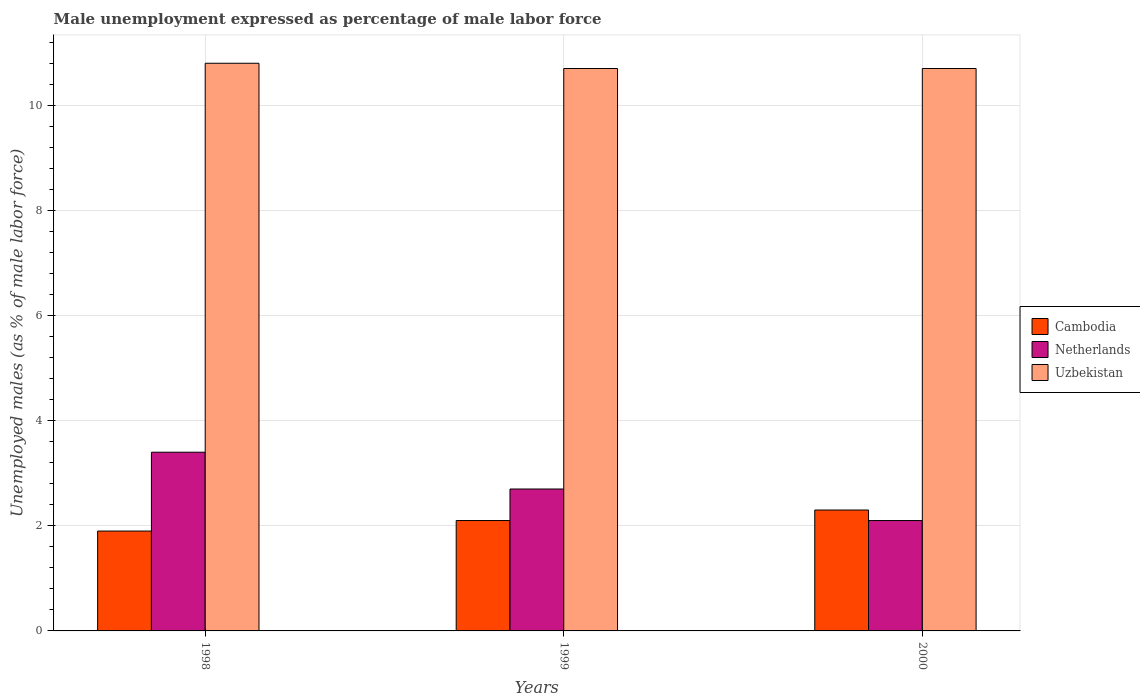How many groups of bars are there?
Ensure brevity in your answer.  3. Are the number of bars on each tick of the X-axis equal?
Keep it short and to the point. Yes. How many bars are there on the 1st tick from the right?
Make the answer very short. 3. What is the label of the 1st group of bars from the left?
Provide a short and direct response. 1998. What is the unemployment in males in in Cambodia in 1998?
Give a very brief answer. 1.9. Across all years, what is the maximum unemployment in males in in Netherlands?
Give a very brief answer. 3.4. Across all years, what is the minimum unemployment in males in in Cambodia?
Make the answer very short. 1.9. In which year was the unemployment in males in in Cambodia maximum?
Give a very brief answer. 2000. What is the total unemployment in males in in Uzbekistan in the graph?
Offer a terse response. 32.2. What is the difference between the unemployment in males in in Cambodia in 1998 and that in 2000?
Your answer should be compact. -0.4. What is the difference between the unemployment in males in in Uzbekistan in 2000 and the unemployment in males in in Cambodia in 1998?
Your response must be concise. 8.8. What is the average unemployment in males in in Cambodia per year?
Ensure brevity in your answer.  2.1. In the year 1998, what is the difference between the unemployment in males in in Netherlands and unemployment in males in in Cambodia?
Make the answer very short. 1.5. In how many years, is the unemployment in males in in Netherlands greater than 10.8 %?
Keep it short and to the point. 0. What is the ratio of the unemployment in males in in Uzbekistan in 1998 to that in 1999?
Keep it short and to the point. 1.01. Is the difference between the unemployment in males in in Netherlands in 1999 and 2000 greater than the difference between the unemployment in males in in Cambodia in 1999 and 2000?
Provide a succinct answer. Yes. What is the difference between the highest and the second highest unemployment in males in in Cambodia?
Offer a terse response. 0.2. What is the difference between the highest and the lowest unemployment in males in in Uzbekistan?
Give a very brief answer. 0.1. In how many years, is the unemployment in males in in Uzbekistan greater than the average unemployment in males in in Uzbekistan taken over all years?
Your answer should be very brief. 1. Is the sum of the unemployment in males in in Uzbekistan in 1998 and 1999 greater than the maximum unemployment in males in in Cambodia across all years?
Ensure brevity in your answer.  Yes. What does the 1st bar from the left in 1999 represents?
Your answer should be very brief. Cambodia. Is it the case that in every year, the sum of the unemployment in males in in Cambodia and unemployment in males in in Netherlands is greater than the unemployment in males in in Uzbekistan?
Provide a short and direct response. No. How many years are there in the graph?
Provide a short and direct response. 3. What is the difference between two consecutive major ticks on the Y-axis?
Your answer should be very brief. 2. Does the graph contain grids?
Your response must be concise. Yes. How many legend labels are there?
Keep it short and to the point. 3. How are the legend labels stacked?
Your answer should be very brief. Vertical. What is the title of the graph?
Give a very brief answer. Male unemployment expressed as percentage of male labor force. What is the label or title of the X-axis?
Ensure brevity in your answer.  Years. What is the label or title of the Y-axis?
Give a very brief answer. Unemployed males (as % of male labor force). What is the Unemployed males (as % of male labor force) in Cambodia in 1998?
Give a very brief answer. 1.9. What is the Unemployed males (as % of male labor force) of Netherlands in 1998?
Provide a short and direct response. 3.4. What is the Unemployed males (as % of male labor force) in Uzbekistan in 1998?
Offer a very short reply. 10.8. What is the Unemployed males (as % of male labor force) of Cambodia in 1999?
Offer a terse response. 2.1. What is the Unemployed males (as % of male labor force) of Netherlands in 1999?
Ensure brevity in your answer.  2.7. What is the Unemployed males (as % of male labor force) in Uzbekistan in 1999?
Make the answer very short. 10.7. What is the Unemployed males (as % of male labor force) in Cambodia in 2000?
Offer a terse response. 2.3. What is the Unemployed males (as % of male labor force) in Netherlands in 2000?
Offer a terse response. 2.1. What is the Unemployed males (as % of male labor force) of Uzbekistan in 2000?
Make the answer very short. 10.7. Across all years, what is the maximum Unemployed males (as % of male labor force) in Cambodia?
Give a very brief answer. 2.3. Across all years, what is the maximum Unemployed males (as % of male labor force) of Netherlands?
Provide a succinct answer. 3.4. Across all years, what is the maximum Unemployed males (as % of male labor force) in Uzbekistan?
Offer a terse response. 10.8. Across all years, what is the minimum Unemployed males (as % of male labor force) in Cambodia?
Your response must be concise. 1.9. Across all years, what is the minimum Unemployed males (as % of male labor force) in Netherlands?
Offer a very short reply. 2.1. Across all years, what is the minimum Unemployed males (as % of male labor force) of Uzbekistan?
Ensure brevity in your answer.  10.7. What is the total Unemployed males (as % of male labor force) in Cambodia in the graph?
Your answer should be very brief. 6.3. What is the total Unemployed males (as % of male labor force) of Uzbekistan in the graph?
Your response must be concise. 32.2. What is the difference between the Unemployed males (as % of male labor force) in Cambodia in 1998 and that in 1999?
Offer a terse response. -0.2. What is the difference between the Unemployed males (as % of male labor force) in Netherlands in 1998 and that in 1999?
Your response must be concise. 0.7. What is the difference between the Unemployed males (as % of male labor force) in Uzbekistan in 1998 and that in 2000?
Offer a terse response. 0.1. What is the difference between the Unemployed males (as % of male labor force) of Netherlands in 1999 and that in 2000?
Offer a very short reply. 0.6. What is the difference between the Unemployed males (as % of male labor force) of Uzbekistan in 1999 and that in 2000?
Offer a terse response. 0. What is the difference between the Unemployed males (as % of male labor force) of Cambodia in 1998 and the Unemployed males (as % of male labor force) of Netherlands in 1999?
Keep it short and to the point. -0.8. What is the difference between the Unemployed males (as % of male labor force) in Cambodia in 1998 and the Unemployed males (as % of male labor force) in Uzbekistan in 1999?
Provide a short and direct response. -8.8. What is the difference between the Unemployed males (as % of male labor force) in Cambodia in 1998 and the Unemployed males (as % of male labor force) in Uzbekistan in 2000?
Your answer should be very brief. -8.8. What is the difference between the Unemployed males (as % of male labor force) of Netherlands in 1998 and the Unemployed males (as % of male labor force) of Uzbekistan in 2000?
Give a very brief answer. -7.3. What is the difference between the Unemployed males (as % of male labor force) of Cambodia in 1999 and the Unemployed males (as % of male labor force) of Netherlands in 2000?
Offer a very short reply. 0. What is the difference between the Unemployed males (as % of male labor force) of Cambodia in 1999 and the Unemployed males (as % of male labor force) of Uzbekistan in 2000?
Provide a short and direct response. -8.6. What is the average Unemployed males (as % of male labor force) in Cambodia per year?
Provide a short and direct response. 2.1. What is the average Unemployed males (as % of male labor force) of Netherlands per year?
Ensure brevity in your answer.  2.73. What is the average Unemployed males (as % of male labor force) of Uzbekistan per year?
Keep it short and to the point. 10.73. In the year 1998, what is the difference between the Unemployed males (as % of male labor force) in Netherlands and Unemployed males (as % of male labor force) in Uzbekistan?
Give a very brief answer. -7.4. In the year 1999, what is the difference between the Unemployed males (as % of male labor force) of Netherlands and Unemployed males (as % of male labor force) of Uzbekistan?
Ensure brevity in your answer.  -8. In the year 2000, what is the difference between the Unemployed males (as % of male labor force) of Cambodia and Unemployed males (as % of male labor force) of Uzbekistan?
Your answer should be compact. -8.4. What is the ratio of the Unemployed males (as % of male labor force) of Cambodia in 1998 to that in 1999?
Make the answer very short. 0.9. What is the ratio of the Unemployed males (as % of male labor force) of Netherlands in 1998 to that in 1999?
Ensure brevity in your answer.  1.26. What is the ratio of the Unemployed males (as % of male labor force) of Uzbekistan in 1998 to that in 1999?
Your response must be concise. 1.01. What is the ratio of the Unemployed males (as % of male labor force) of Cambodia in 1998 to that in 2000?
Ensure brevity in your answer.  0.83. What is the ratio of the Unemployed males (as % of male labor force) in Netherlands in 1998 to that in 2000?
Keep it short and to the point. 1.62. What is the ratio of the Unemployed males (as % of male labor force) of Uzbekistan in 1998 to that in 2000?
Your answer should be very brief. 1.01. What is the ratio of the Unemployed males (as % of male labor force) of Cambodia in 1999 to that in 2000?
Ensure brevity in your answer.  0.91. What is the difference between the highest and the second highest Unemployed males (as % of male labor force) of Cambodia?
Offer a terse response. 0.2. What is the difference between the highest and the second highest Unemployed males (as % of male labor force) of Uzbekistan?
Offer a terse response. 0.1. 